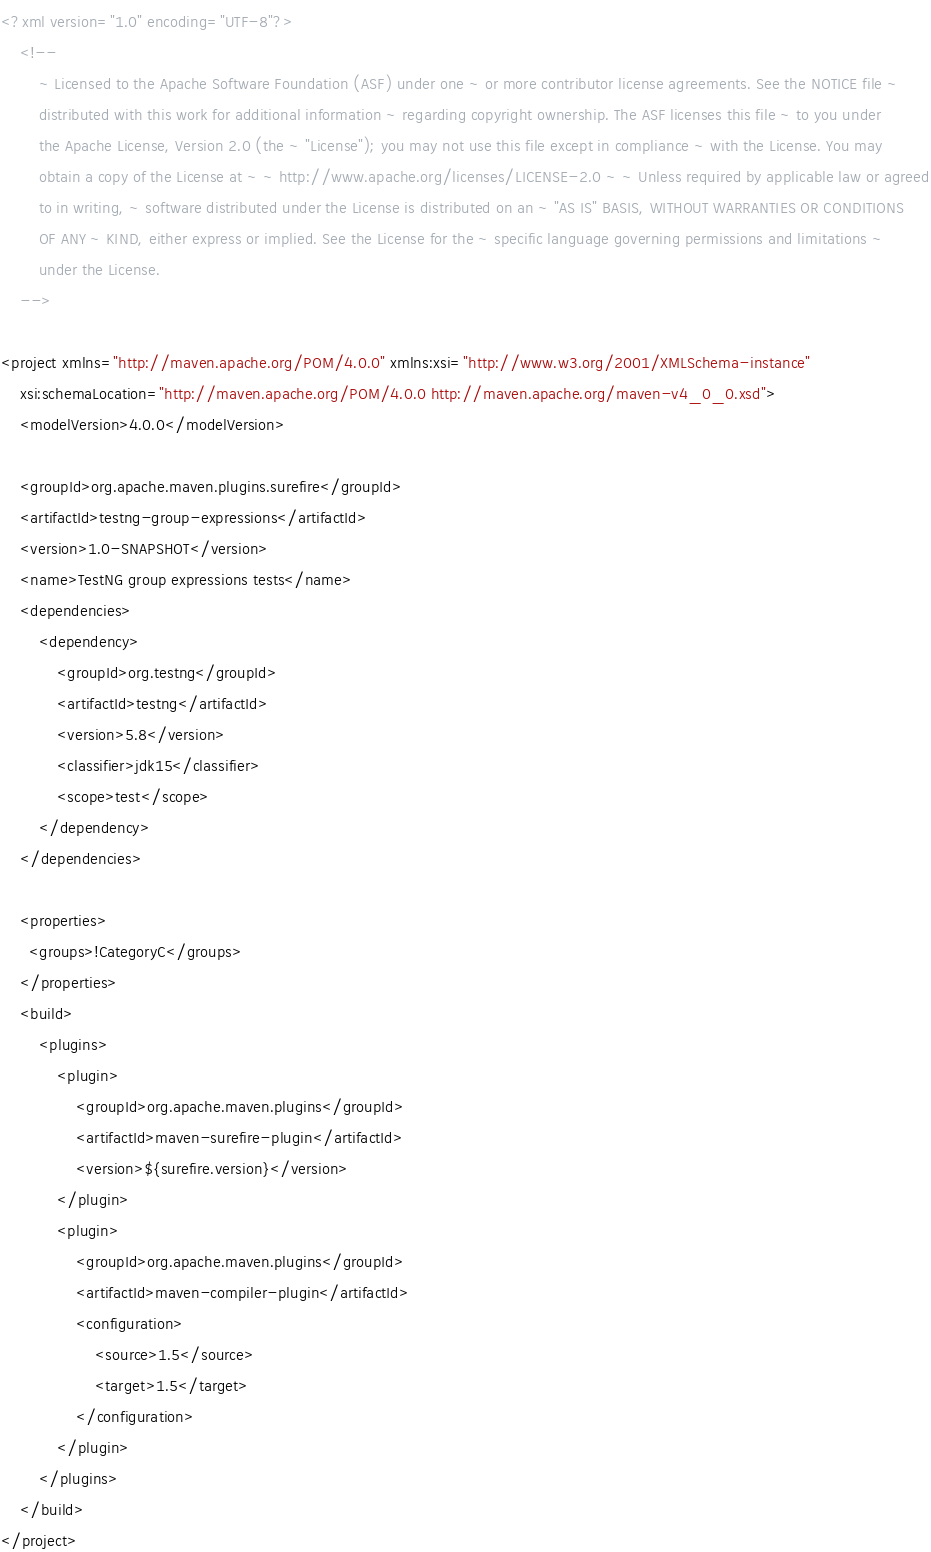Convert code to text. <code><loc_0><loc_0><loc_500><loc_500><_XML_><?xml version="1.0" encoding="UTF-8"?>
    <!--
        ~ Licensed to the Apache Software Foundation (ASF) under one ~ or more contributor license agreements. See the NOTICE file ~
        distributed with this work for additional information ~ regarding copyright ownership. The ASF licenses this file ~ to you under
        the Apache License, Version 2.0 (the ~ "License"); you may not use this file except in compliance ~ with the License. You may
        obtain a copy of the License at ~ ~ http://www.apache.org/licenses/LICENSE-2.0 ~ ~ Unless required by applicable law or agreed
        to in writing, ~ software distributed under the License is distributed on an ~ "AS IS" BASIS, WITHOUT WARRANTIES OR CONDITIONS
        OF ANY ~ KIND, either express or implied. See the License for the ~ specific language governing permissions and limitations ~
        under the License.
    -->

<project xmlns="http://maven.apache.org/POM/4.0.0" xmlns:xsi="http://www.w3.org/2001/XMLSchema-instance"
    xsi:schemaLocation="http://maven.apache.org/POM/4.0.0 http://maven.apache.org/maven-v4_0_0.xsd">
    <modelVersion>4.0.0</modelVersion>

    <groupId>org.apache.maven.plugins.surefire</groupId>
    <artifactId>testng-group-expressions</artifactId>
    <version>1.0-SNAPSHOT</version>
    <name>TestNG group expressions tests</name>
    <dependencies>
        <dependency>
            <groupId>org.testng</groupId>
            <artifactId>testng</artifactId>
            <version>5.8</version>
            <classifier>jdk15</classifier>
            <scope>test</scope>
        </dependency>
    </dependencies>
  
    <properties>
      <groups>!CategoryC</groups>
    </properties>
    <build>
        <plugins>
            <plugin>
                <groupId>org.apache.maven.plugins</groupId>
                <artifactId>maven-surefire-plugin</artifactId>
                <version>${surefire.version}</version>
            </plugin>
            <plugin>
                <groupId>org.apache.maven.plugins</groupId>
                <artifactId>maven-compiler-plugin</artifactId>
                <configuration>
                    <source>1.5</source>
                    <target>1.5</target>
                </configuration>
            </plugin>
        </plugins>
    </build>
</project>
</code> 